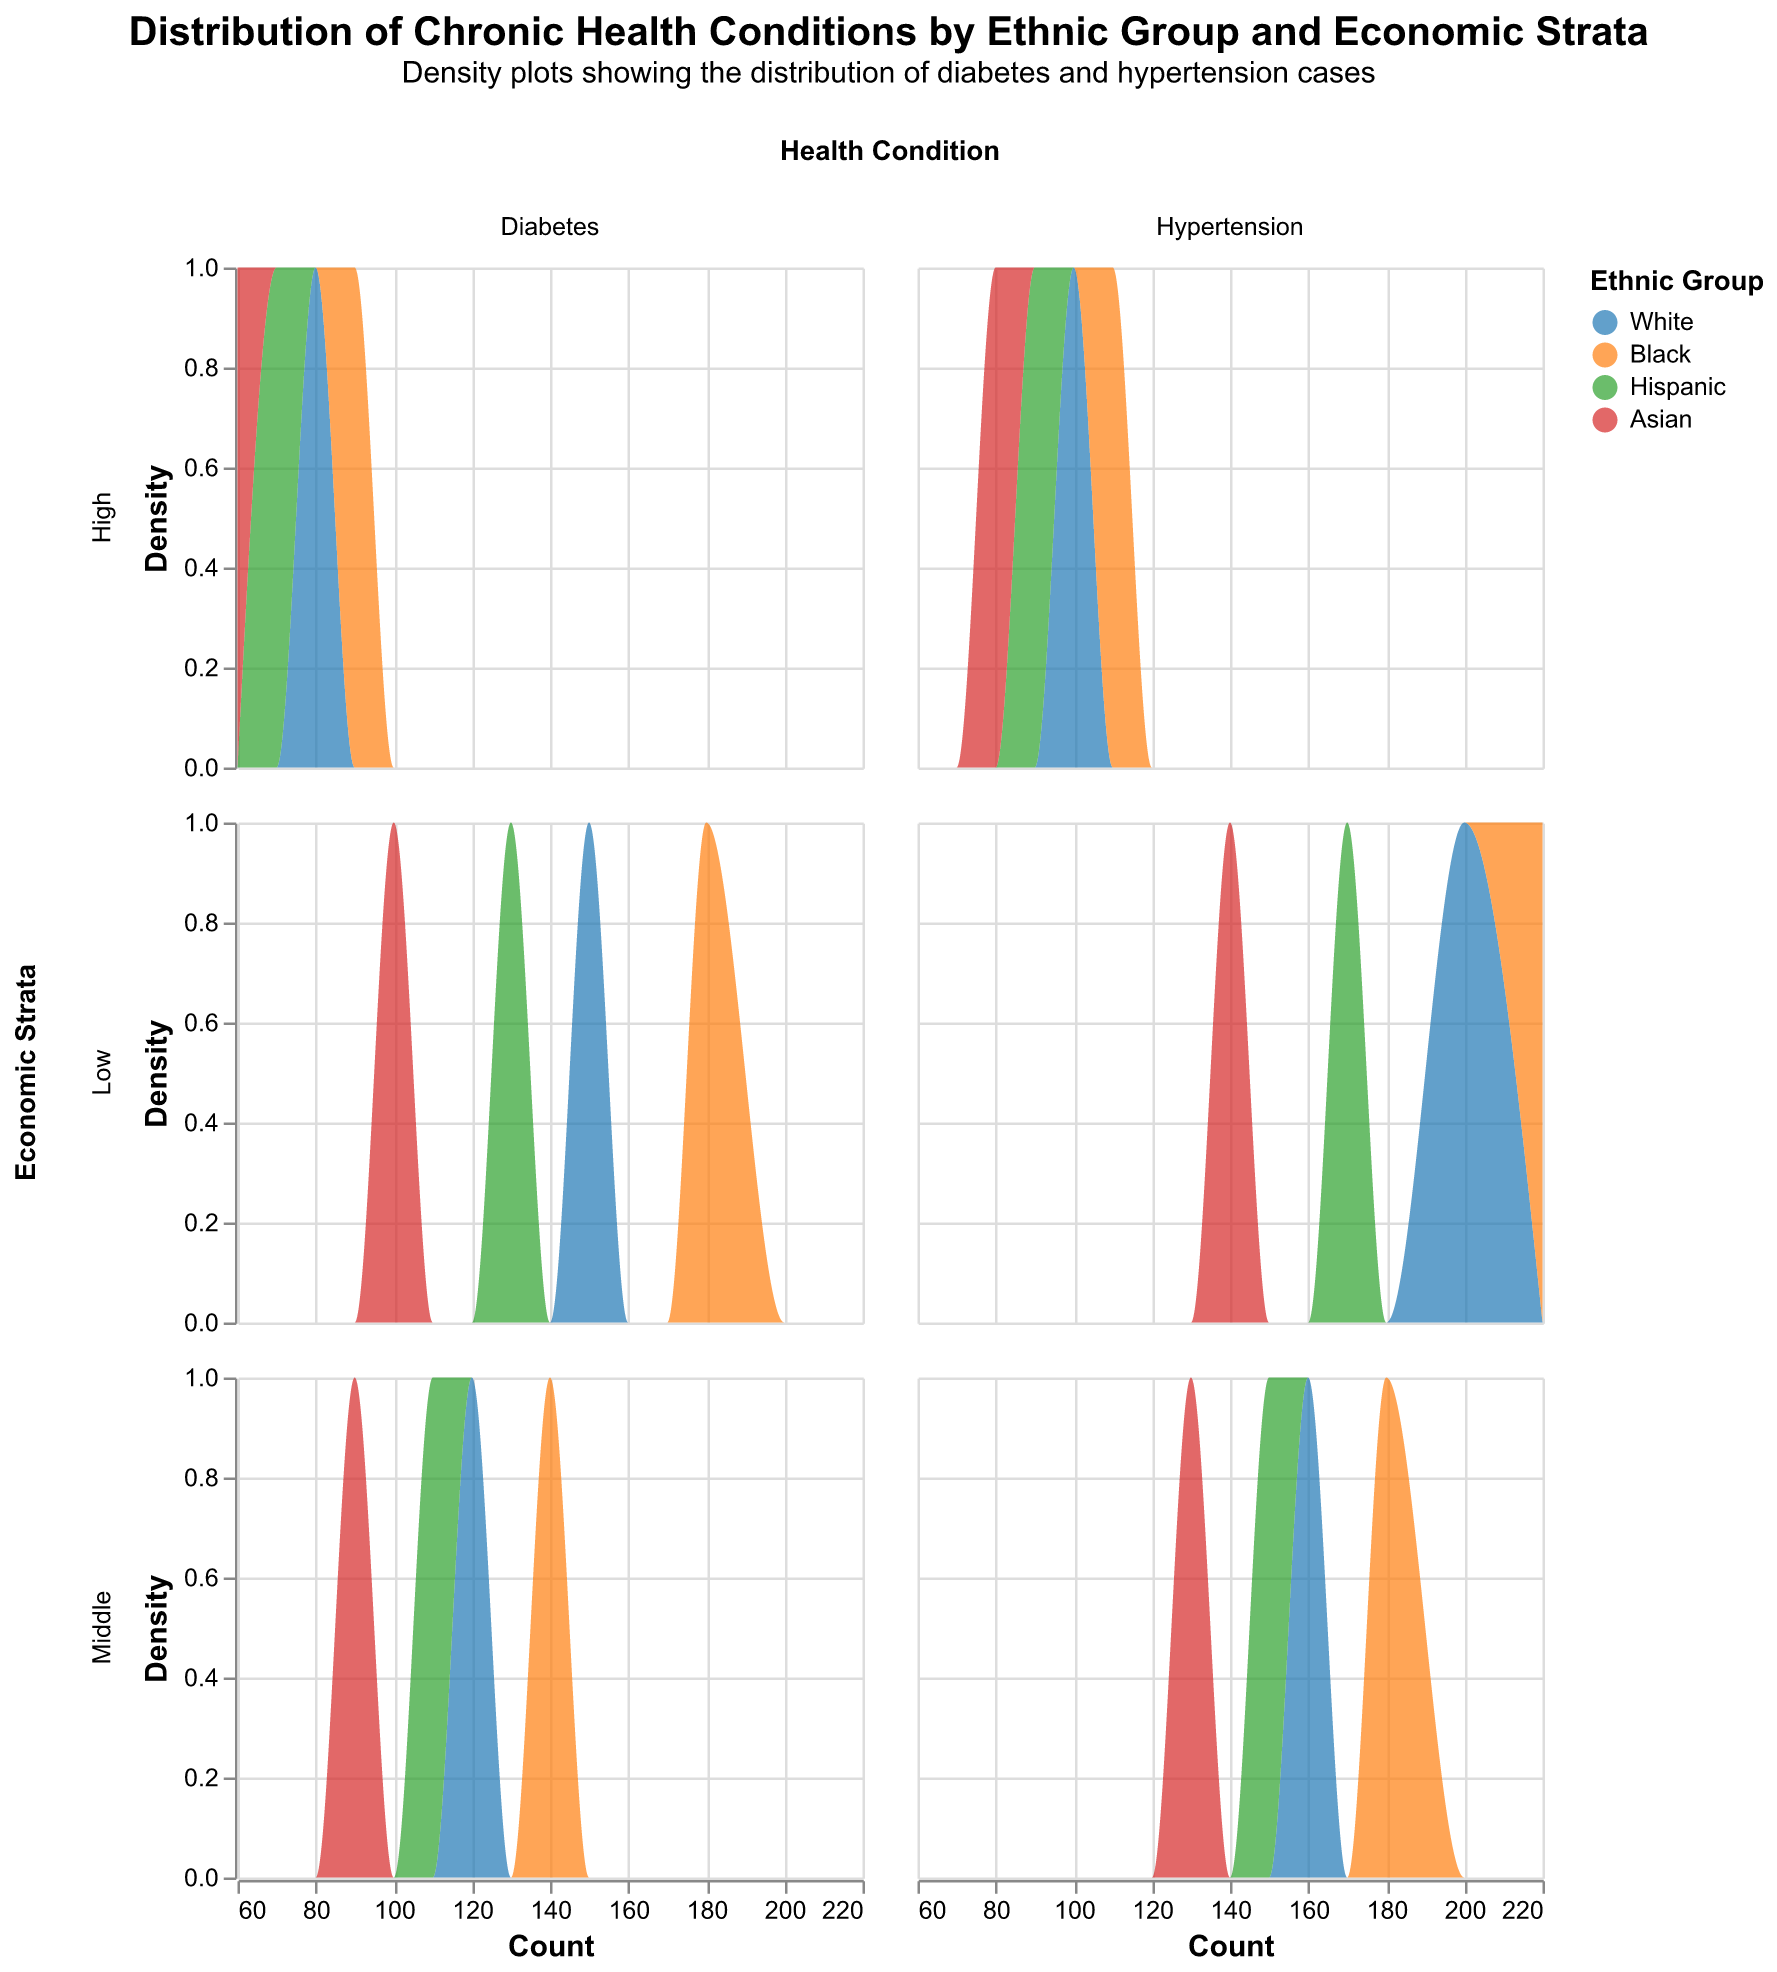What are the health conditions being compared in the figure? The title of the plot mentions "chronic health conditions" and the column facet titles indicate the conditions being compared. The conditions are Diabetes and Hypertension.
Answer: Diabetes and Hypertension Which economic strata show the highest density for hypertension cases? By examining the density plots for Hypertension under different economic strata, the Low economic strata show the highest peak density.
Answer: Low How does the distribution of diabetes cases for the White ethnic group change across economic strata? Observing the density plots for Diabetes and focusing on the White ethnic group, as we move from Low to High economic strata, the density of diabetes cases decreases.
Answer: Decreases Among middle economic strata, which ethnic group has a higher density for diabetes cases? Look at the Diabetes condition plot for Middle economic strata and compare the peaks of different ethnic groups' density curves. The Black ethnic group shows a higher density.
Answer: Black For the high economic strata, compare the density distributions of hypertension between Black and Asian ethnic groups. Compare the density curves for Hypertension in High economic strata. The Black ethnic group has a denser distribution than the Asian ethnic group.
Answer: Black Which ethnic group shows the lowest density of diabetes cases in the low economic strata? For Diabetes in Low economic strata, compare the density plots of each ethnic group. The Asian ethnic group has the lowest density.
Answer: Asian In the middle economic strata, which health condition shows a higher density for the White ethnic group? Compare the density plots for both Diabetes and Hypertension in the Middle economic strata for the White ethnic group. Hypertension shows a higher density.
Answer: Hypertension Which economic strata has the highest density for diabetes cases among the Hispanic ethnic group? By looking at the density plots for Diabetes among the Hispanic ethnic group across different economic strata, the Low economic strata shows the highest density.
Answer: Low How does the distribution of hypertension cases for the Black ethnic group compare between low and high economic strata? Compare the density plots for Hypertension among the Black ethnic group in Low and High economic strata. The Low economic strata show a higher peak density compared to High economic strata.
Answer: Low What is the subtitle of the figure? The subtitle is mentioned right below the main title of the figure.
Answer: Density plots showing the distribution of diabetes and hypertension cases 